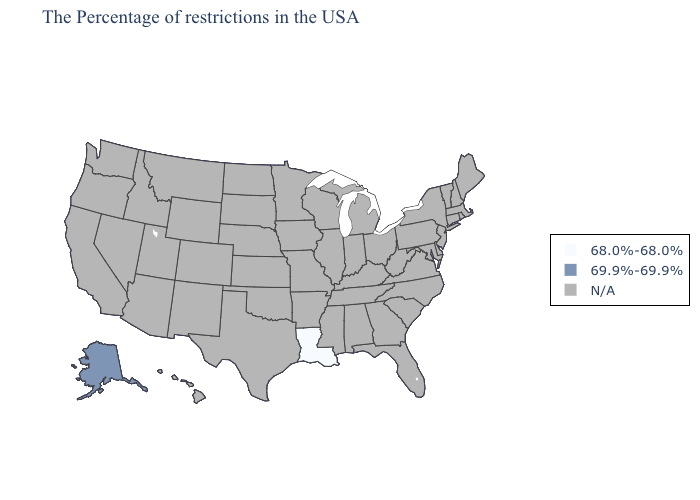What is the value of Utah?
Be succinct. N/A. What is the lowest value in the USA?
Write a very short answer. 68.0%-68.0%. What is the value of Oklahoma?
Write a very short answer. N/A. Which states have the highest value in the USA?
Give a very brief answer. Alaska. Which states have the lowest value in the USA?
Short answer required. Louisiana. Name the states that have a value in the range 68.0%-68.0%?
Answer briefly. Louisiana. What is the lowest value in the USA?
Short answer required. 68.0%-68.0%. Does the map have missing data?
Give a very brief answer. Yes. Is the legend a continuous bar?
Concise answer only. No. What is the highest value in the USA?
Answer briefly. 69.9%-69.9%. 